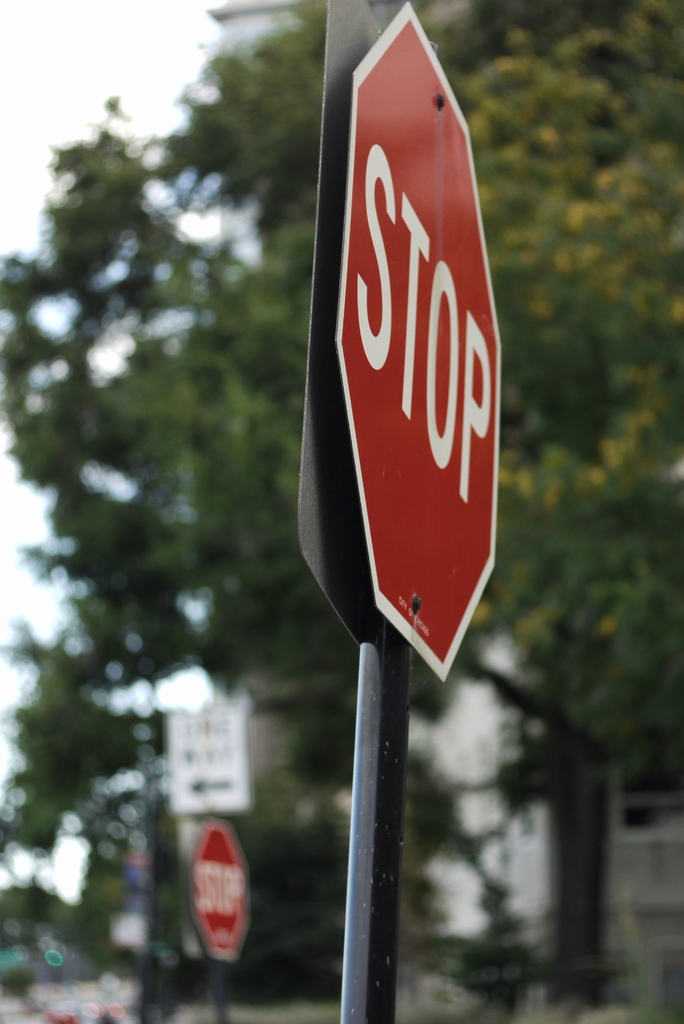Can you describe the main features of this image for me? The image features a red stop sign with bold, white lettering that immediately draws the eye. This quintessential traffic sign is securely affixed to a sleek, black metal pole. The stop sign is positioned against a soft-focus backdrop, where the outlines of lush trees paint a calm suburban atmosphere. A hint of a white building suggests a residential or perhaps institutional setting. This tableau is given life by the bokeh effect—the aesthetic quality of the blur—lending a gentle touch to what is typically a rigid symbol of road safety. Additionally, the repetition of another stop sign in the background subtly reinforces the theme of safety and the prevalence of traffic control in daily life. 